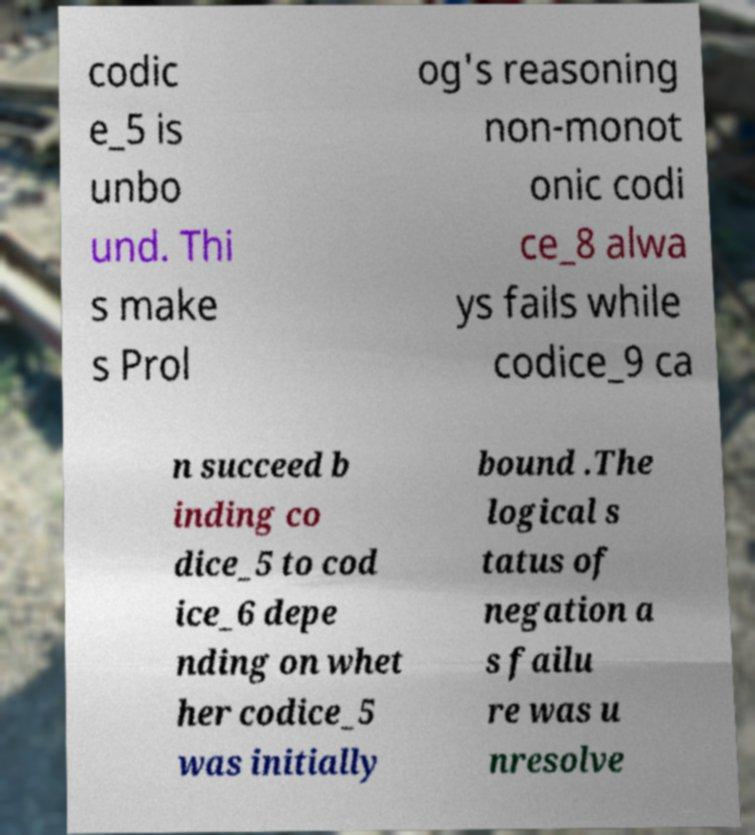For documentation purposes, I need the text within this image transcribed. Could you provide that? codic e_5 is unbo und. Thi s make s Prol og's reasoning non-monot onic codi ce_8 alwa ys fails while codice_9 ca n succeed b inding co dice_5 to cod ice_6 depe nding on whet her codice_5 was initially bound .The logical s tatus of negation a s failu re was u nresolve 